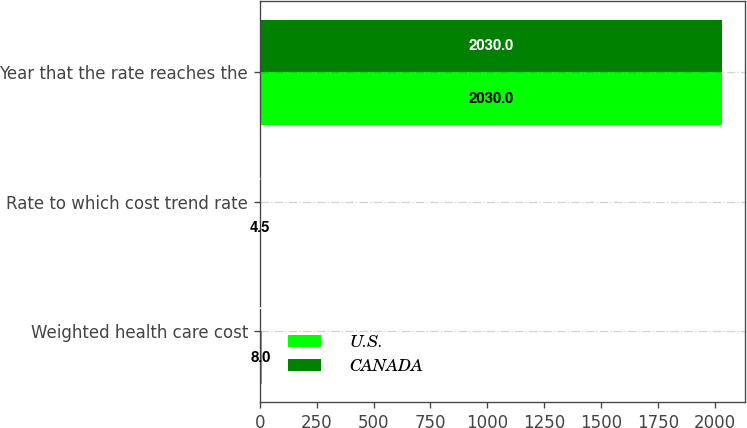<chart> <loc_0><loc_0><loc_500><loc_500><stacked_bar_chart><ecel><fcel>Weighted health care cost<fcel>Rate to which cost trend rate<fcel>Year that the rate reaches the<nl><fcel>U.S.<fcel>8<fcel>4.5<fcel>2030<nl><fcel>CANADA<fcel>7.5<fcel>4.5<fcel>2030<nl></chart> 